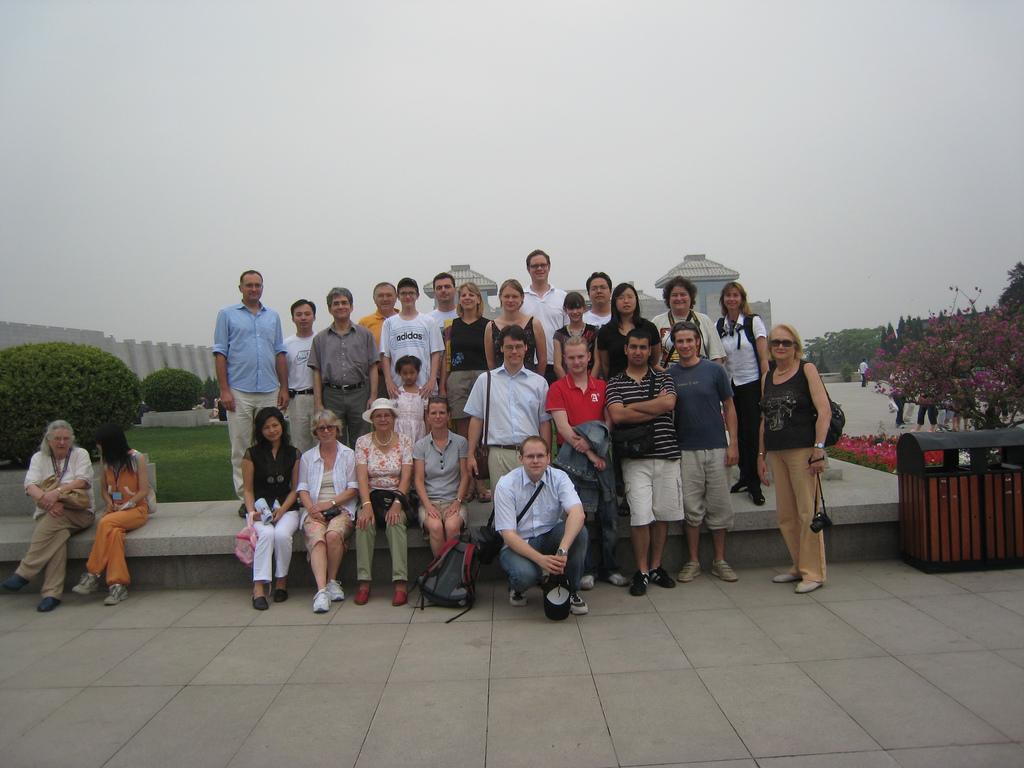Describe this image in one or two sentences. There are group of people where few among them are standing and the remaining are sitting and there are few plants and a building behind them. 